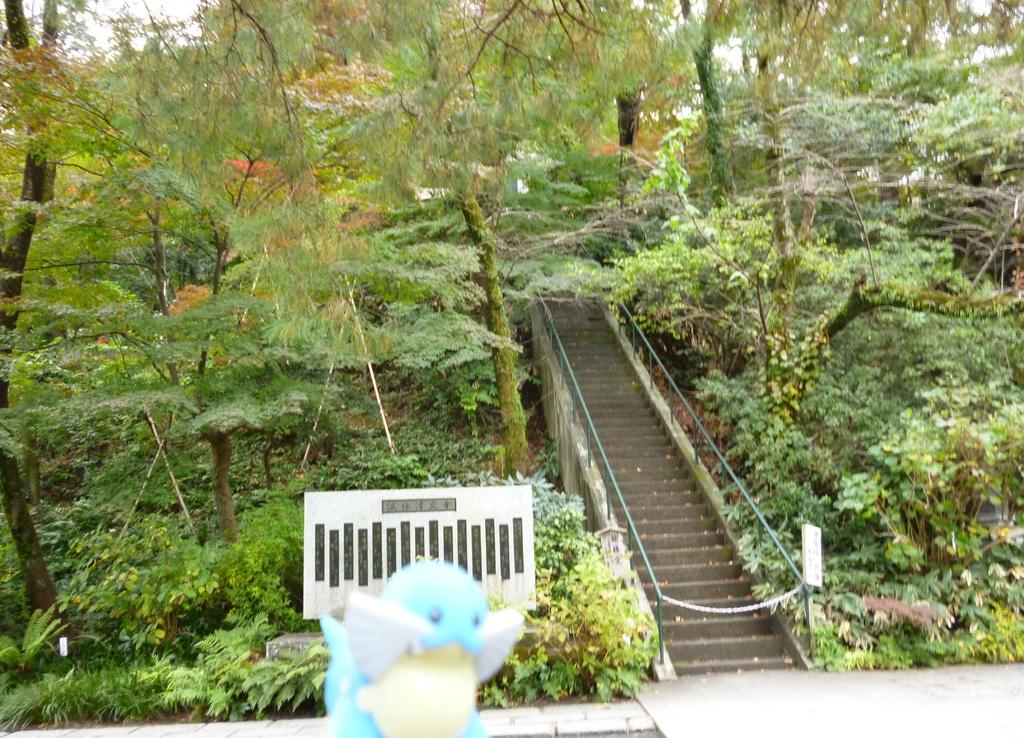What type of natural environment is depicted in the image? There is a forest area with trees and plants in the image. What architectural feature can be seen in the image? There are steps with railing in the image. What object is near the steps in the image? There is a doll with a board on it near the steps in the image. What type of basketball operation is taking place in the image? There is no basketball operation present in the image; it features a forest area, steps with railing, and a doll with a board on it. 